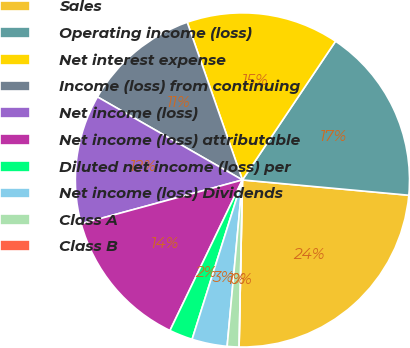Convert chart. <chart><loc_0><loc_0><loc_500><loc_500><pie_chart><fcel>Sales<fcel>Operating income (loss)<fcel>Net interest expense<fcel>Income (loss) from continuing<fcel>Net income (loss)<fcel>Net income (loss) attributable<fcel>Diluted net income (loss) per<fcel>Net income (loss) Dividends<fcel>Class A<fcel>Class B<nl><fcel>23.86%<fcel>17.05%<fcel>14.77%<fcel>11.36%<fcel>12.5%<fcel>13.64%<fcel>2.27%<fcel>3.41%<fcel>1.14%<fcel>0.0%<nl></chart> 